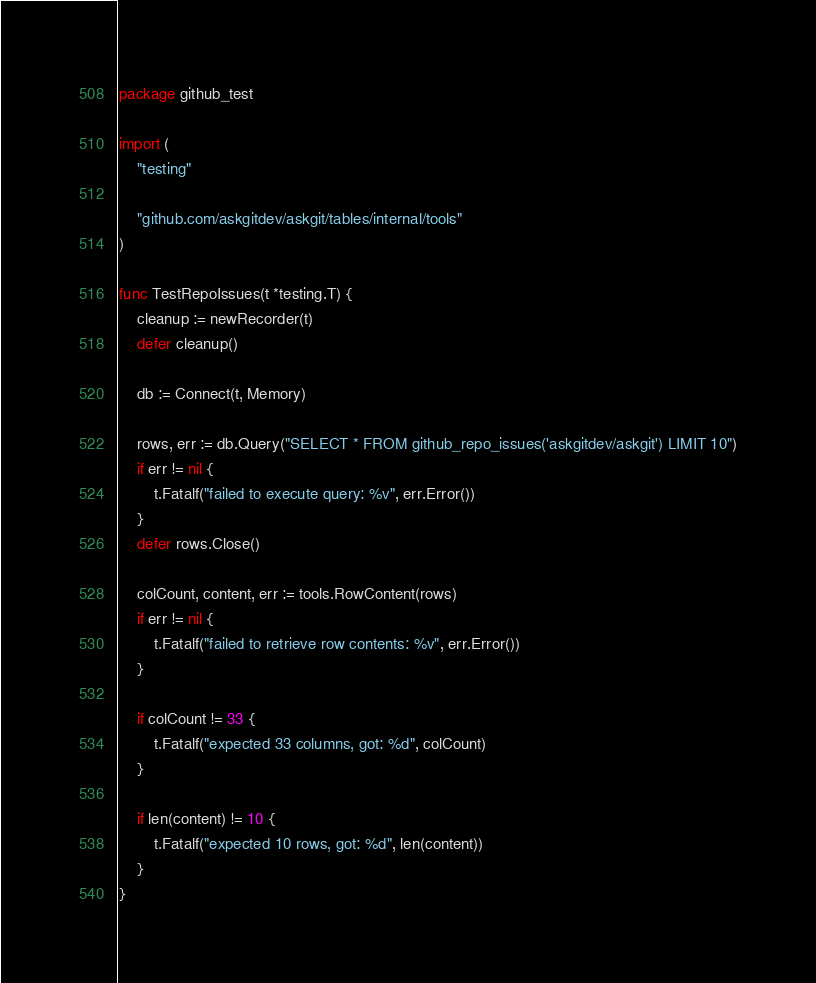<code> <loc_0><loc_0><loc_500><loc_500><_Go_>package github_test

import (
	"testing"

	"github.com/askgitdev/askgit/tables/internal/tools"
)

func TestRepoIssues(t *testing.T) {
	cleanup := newRecorder(t)
	defer cleanup()

	db := Connect(t, Memory)

	rows, err := db.Query("SELECT * FROM github_repo_issues('askgitdev/askgit') LIMIT 10")
	if err != nil {
		t.Fatalf("failed to execute query: %v", err.Error())
	}
	defer rows.Close()

	colCount, content, err := tools.RowContent(rows)
	if err != nil {
		t.Fatalf("failed to retrieve row contents: %v", err.Error())
	}

	if colCount != 33 {
		t.Fatalf("expected 33 columns, got: %d", colCount)
	}

	if len(content) != 10 {
		t.Fatalf("expected 10 rows, got: %d", len(content))
	}
}
</code> 